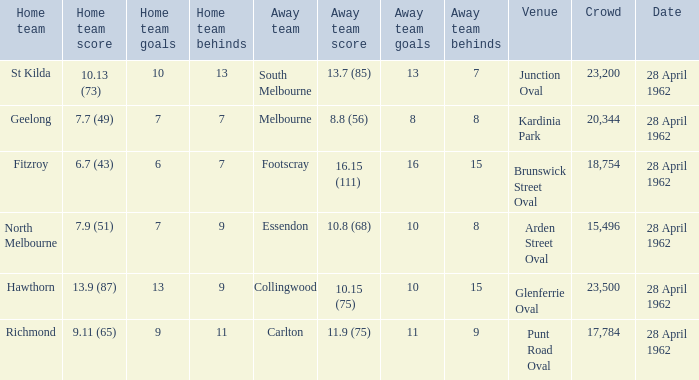Parse the full table. {'header': ['Home team', 'Home team score', 'Home team goals', 'Home team behinds', 'Away team', 'Away team score', 'Away team goals', 'Away team behinds', 'Venue', 'Crowd', 'Date'], 'rows': [['St Kilda', '10.13 (73)', '10', '13', 'South Melbourne', '13.7 (85)', '13', '7', 'Junction Oval', '23,200', '28 April 1962'], ['Geelong', '7.7 (49)', '7', '7', 'Melbourne', '8.8 (56)', '8', '8', 'Kardinia Park', '20,344', '28 April 1962'], ['Fitzroy', '6.7 (43)', '6', '7', 'Footscray', '16.15 (111)', '16', '15', 'Brunswick Street Oval', '18,754', '28 April 1962'], ['North Melbourne', '7.9 (51)', '7', '9', 'Essendon', '10.8 (68)', '10', '8', 'Arden Street Oval', '15,496', '28 April 1962'], ['Hawthorn', '13.9 (87)', '13', '9', 'Collingwood', '10.15 (75)', '10', '15', 'Glenferrie Oval', '23,500', '28 April 1962'], ['Richmond', '9.11 (65)', '9', '11', 'Carlton', '11.9 (75)', '11', '9', 'Punt Road Oval', '17,784', '28 April 1962']]} What away team played at Brunswick Street Oval? Footscray. 